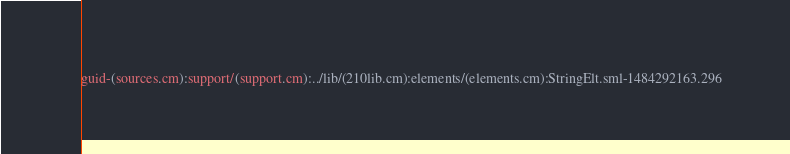<code> <loc_0><loc_0><loc_500><loc_500><_SML_>guid-(sources.cm):support/(support.cm):../lib/(210lib.cm):elements/(elements.cm):StringElt.sml-1484292163.296
</code> 